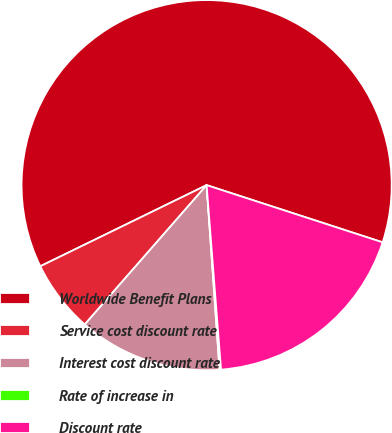<chart> <loc_0><loc_0><loc_500><loc_500><pie_chart><fcel>Worldwide Benefit Plans<fcel>Service cost discount rate<fcel>Interest cost discount rate<fcel>Rate of increase in<fcel>Discount rate<nl><fcel>62.23%<fcel>6.34%<fcel>12.55%<fcel>0.13%<fcel>18.76%<nl></chart> 